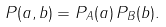Convert formula to latex. <formula><loc_0><loc_0><loc_500><loc_500>P ( a , b ) = P _ { A } ( a ) \, P _ { B } ( b ) .</formula> 